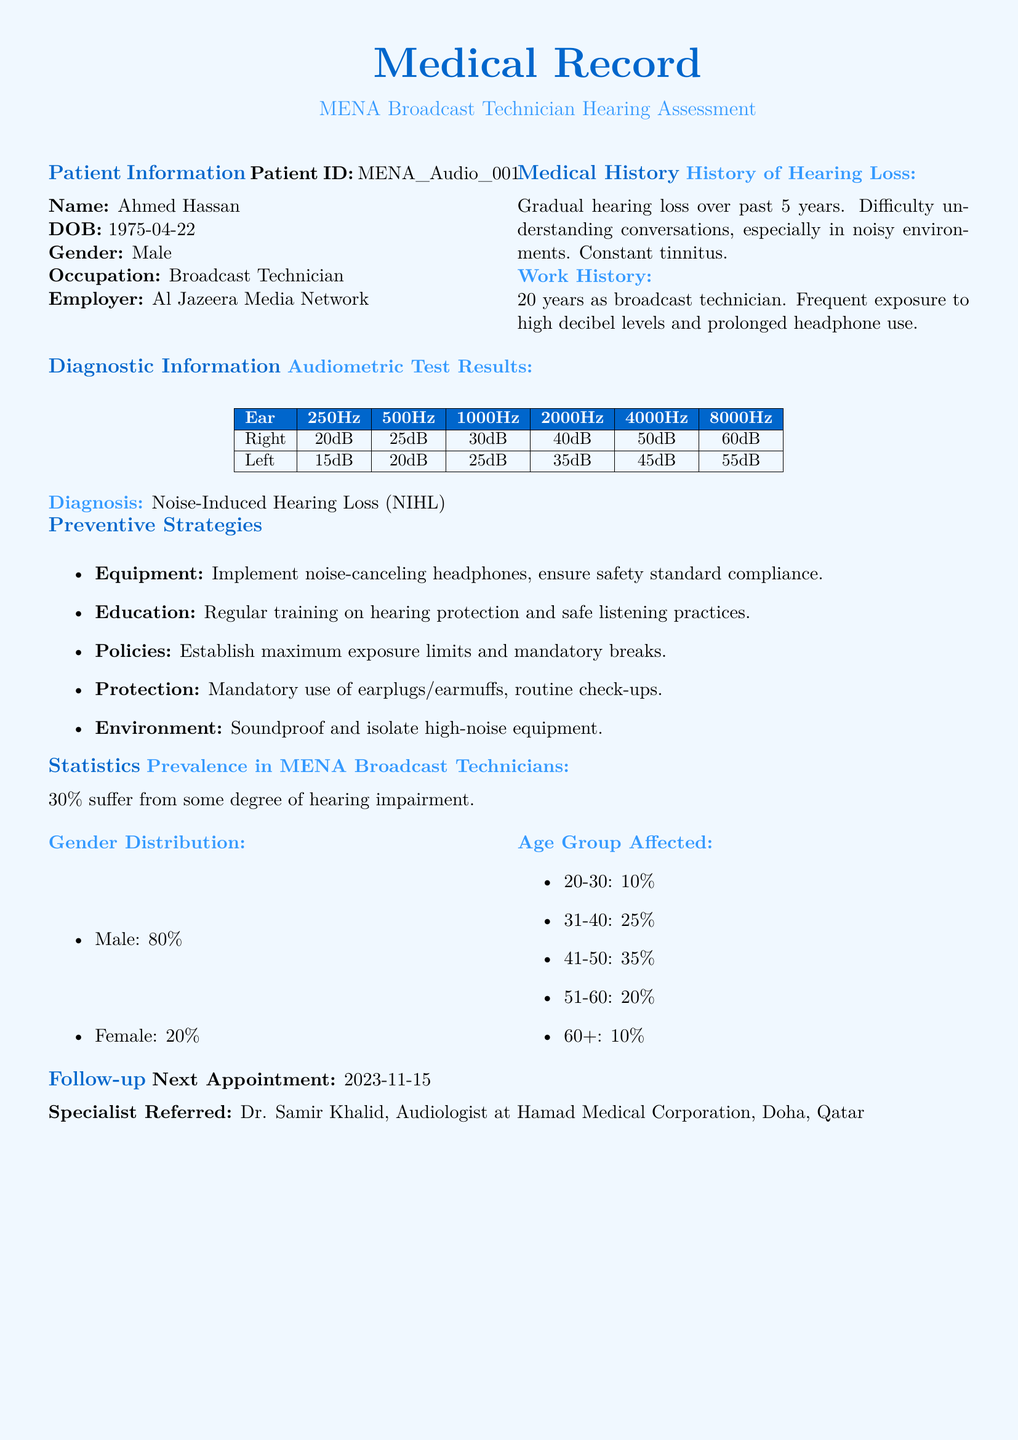What is the patient ID? The patient ID is listed under Patient Information as MENA_Audio_001.
Answer: MENA_Audio_001 What is the diagnosis of the patient? The diagnosis is found in the Diagnostic Information section, which states Noise-Induced Hearing Loss.
Answer: Noise-Induced Hearing Loss What percentage of MENA broadcast technicians suffer from hearing impairment? This statistic is mentioned in the Statistics section, indicating that 30% suffer from some degree of hearing impairment.
Answer: 30% What is the name of the specialist the patient is referred to? The specialist's name is listed in the Follow-up section as Dr. Samir Khalid.
Answer: Dr. Samir Khalid How long has the patient worked as a broadcast technician? The work history details indicate 20 years as a broadcast technician.
Answer: 20 years What is the age of the patient? The age can be calculated from the date of birth provided, which is April 22, 1975, making the patient 48 years old as of the report date.
Answer: 48 years What preventive strategy is suggested regarding equipment? The preventive strategy for equipment mentioned is to implement noise-canceling headphones.
Answer: noise-canceling headphones What is the last appointment date for the patient? The next appointment date is provided in the Follow-up section as November 15, 2023.
Answer: 2023-11-15 What age group has the highest percentage affected by hearing loss? The age group affected most is listed in the Statistics section as 41-50 years, with 35%.
Answer: 41-50 